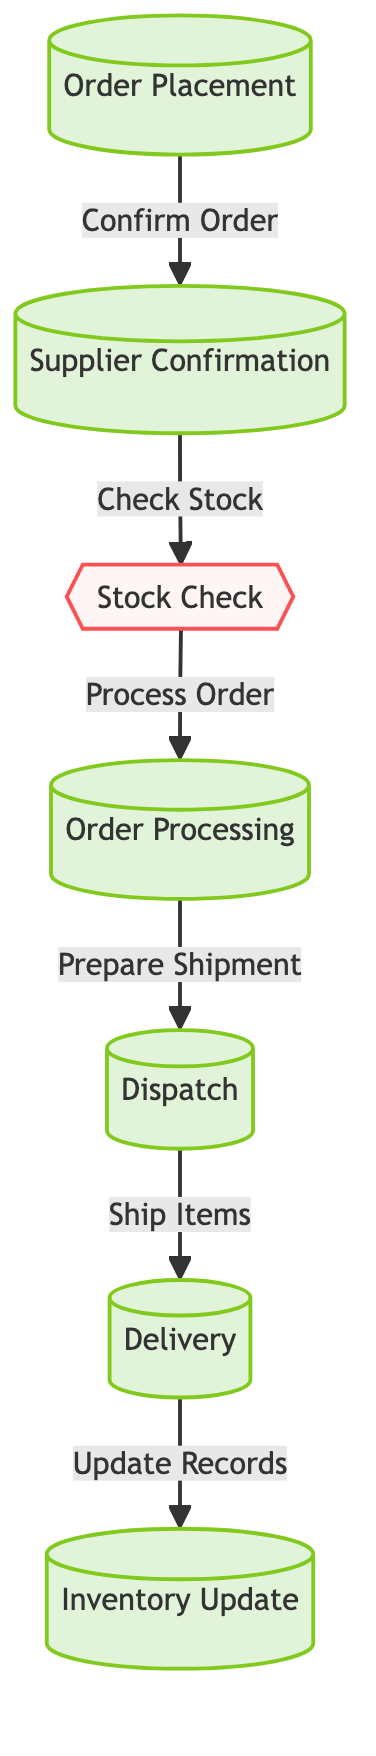What is the first step in the inventory management workflow? The diagram starts with the node labeled "Order Placement," indicating it is the first step in the workflow.
Answer: Order Placement How many total steps are depicted in the diagram? There are six steps shown in the diagram: Order Placement, Supplier Confirmation, Stock Check, Order Processing, Dispatch, and Delivery. Counting these nodes gives us the total.
Answer: Six What action follows the "Supplier Confirmation"? From the diagram, the action "Check Stock" directly follows the "Supplier Confirmation," as indicated by the arrow connecting them.
Answer: Check Stock What is the last step in the workflow? The final node in the flowchart is labeled "Inventory Update," indicating it is the last step after the delivery of items.
Answer: Inventory Update What does the "Stock Check" node lead to? The "Stock Check" node leads to the "Order Processing" node, as shown by the connecting arrow in the flowchart.
Answer: Order Processing Which step involves preparing the items for shipment? The diagram indicates that "Order Processing" is the step where the items are prepared for shipment, as indicated by the label in the flowchart.
Answer: Order Processing What two actions occur after “Dispatch”? According to the diagram, after "Dispatch," the actions that occur are "Ship Items" (leading to "Delivery") and "Update Records" (after delivery).
Answer: Ship Items and Update Records Which process comes immediately after "Delivery"? The diagram shows that the process following "Delivery" is "Inventory Update," as connected by the arrow from the delivery node.
Answer: Inventory Update In total, how many actions are there in the workflow? The diagram depicts three actions: Stock Check, Prepare Shipment, and Ship Items. Counting these provides the total number of actions.
Answer: Three 